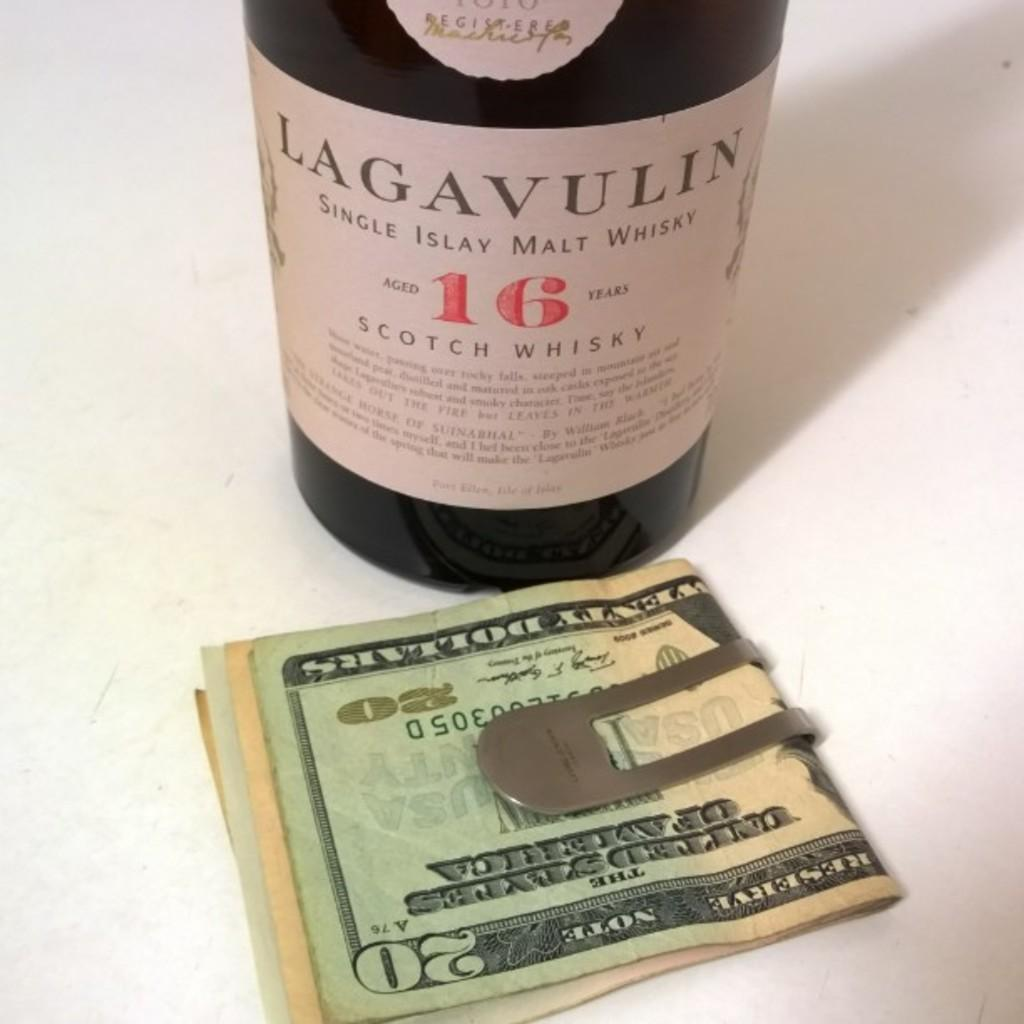<image>
Write a terse but informative summary of the picture. bottle of lagavulin scotch whisky and moneyclip holding several bills including a $20 bill 